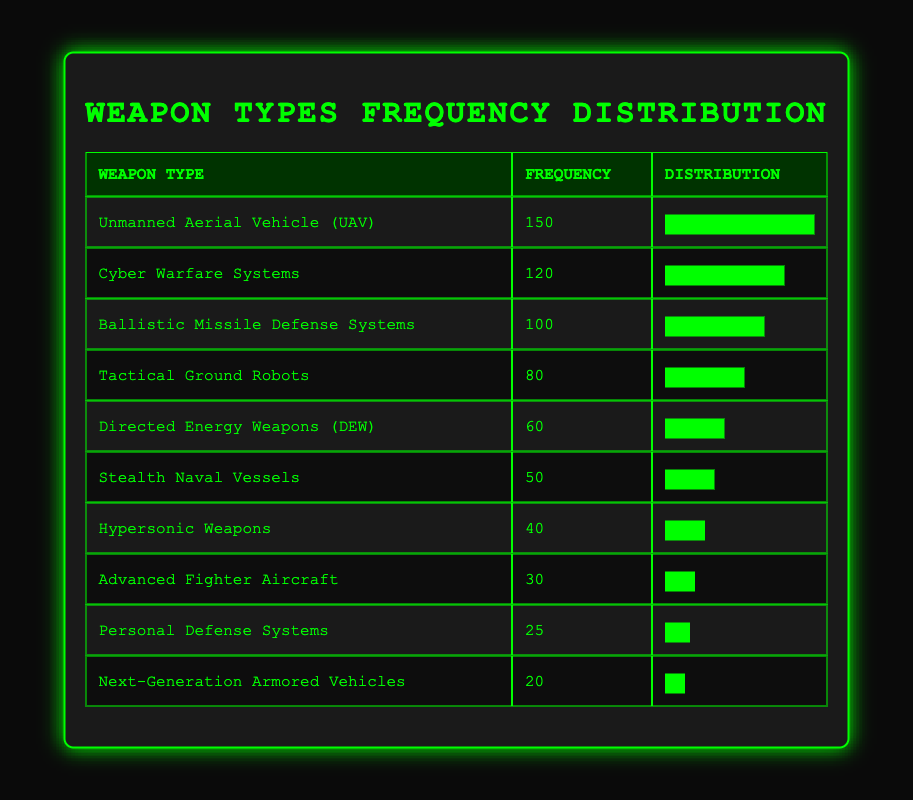What is the most frequently developed weapon type in the past decade? The most frequently developed weapon type can be found by looking for the highest frequency value in the table. The Unmanned Aerial Vehicle (UAV) has the highest frequency of 150.
Answer: Unmanned Aerial Vehicle (UAV) How many more Cyber Warfare Systems were developed compared to Tactical Ground Robots? To find the difference, I subtract the frequency of Tactical Ground Robots (80) from that of Cyber Warfare Systems (120). The calculation is 120 - 80 = 40.
Answer: 40 Is the frequency of Stealth Naval Vessels greater than that of Hypersonic Weapons? By comparing the frequencies, Stealth Naval Vessels have a frequency of 50, while Hypersonic Weapons have a frequency of 40. Since 50 is greater than 40, the answer is yes.
Answer: Yes What is the average frequency of all weapon types listed? To calculate the average frequency, I sum all the frequencies (150 + 120 + 100 + 80 + 60 + 50 + 40 + 30 + 25 + 20 = 755) and divide by the number of weapon types (10). Therefore, the average is 755 / 10 = 75.5.
Answer: 75.5 How many weapon types have a frequency greater than 60? I will count the number of weapon types with frequencies greater than 60: UAV (150), Cyber Warfare Systems (120), Ballistic Missile Defense Systems (100), and Tactical Ground Robots (80). This totals to 4 weapon types.
Answer: 4 What is the difference in frequency between the most and least developed weapon types? The most developed weapon type is the Unmanned Aerial Vehicle (UAV) with a frequency of 150, and the least developed is Next-Generation Armored Vehicles with a frequency of 20. I calculate the difference as 150 - 20 = 130.
Answer: 130 Did the number of Advanced Fighter Aircraft developed exceed that of Next-Generation Armored Vehicles? The frequency of Advanced Fighter Aircraft is 30, while the frequency of Next-Generation Armored Vehicles is 20. Since 30 is greater than 20, the answer is yes.
Answer: Yes What percentage of the total frequencies does the frequency of Directed Energy Weapons (DEW) represent? First, I find the total frequency, which is 755. Then I calculate the percentage of DEW's frequency (60) out of this total as (60 / 755) * 100, which equals approximately 7.95%.
Answer: 7.95% 